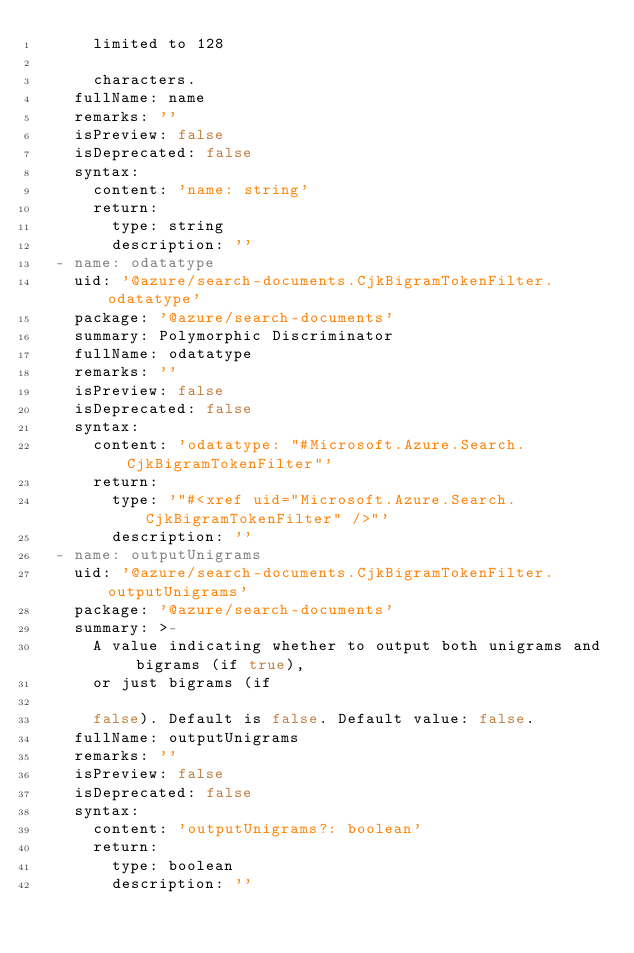Convert code to text. <code><loc_0><loc_0><loc_500><loc_500><_YAML_>      limited to 128

      characters.
    fullName: name
    remarks: ''
    isPreview: false
    isDeprecated: false
    syntax:
      content: 'name: string'
      return:
        type: string
        description: ''
  - name: odatatype
    uid: '@azure/search-documents.CjkBigramTokenFilter.odatatype'
    package: '@azure/search-documents'
    summary: Polymorphic Discriminator
    fullName: odatatype
    remarks: ''
    isPreview: false
    isDeprecated: false
    syntax:
      content: 'odatatype: "#Microsoft.Azure.Search.CjkBigramTokenFilter"'
      return:
        type: '"#<xref uid="Microsoft.Azure.Search.CjkBigramTokenFilter" />"'
        description: ''
  - name: outputUnigrams
    uid: '@azure/search-documents.CjkBigramTokenFilter.outputUnigrams'
    package: '@azure/search-documents'
    summary: >-
      A value indicating whether to output both unigrams and bigrams (if true),
      or just bigrams (if

      false). Default is false. Default value: false.
    fullName: outputUnigrams
    remarks: ''
    isPreview: false
    isDeprecated: false
    syntax:
      content: 'outputUnigrams?: boolean'
      return:
        type: boolean
        description: ''
</code> 